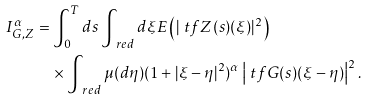Convert formula to latex. <formula><loc_0><loc_0><loc_500><loc_500>I ^ { \alpha } _ { G , Z } & = \int _ { 0 } ^ { T } d s \int _ { \ r e d } d \xi E \left ( | \ t f Z ( s ) ( \xi ) | ^ { 2 } \right ) \\ & \quad \times \int _ { \ r e d } \mu ( d \eta ) ( 1 + | \xi - \eta | ^ { 2 } ) ^ { \alpha } \left | \ t f G ( s ) ( \xi - \eta ) \right | ^ { 2 } .</formula> 